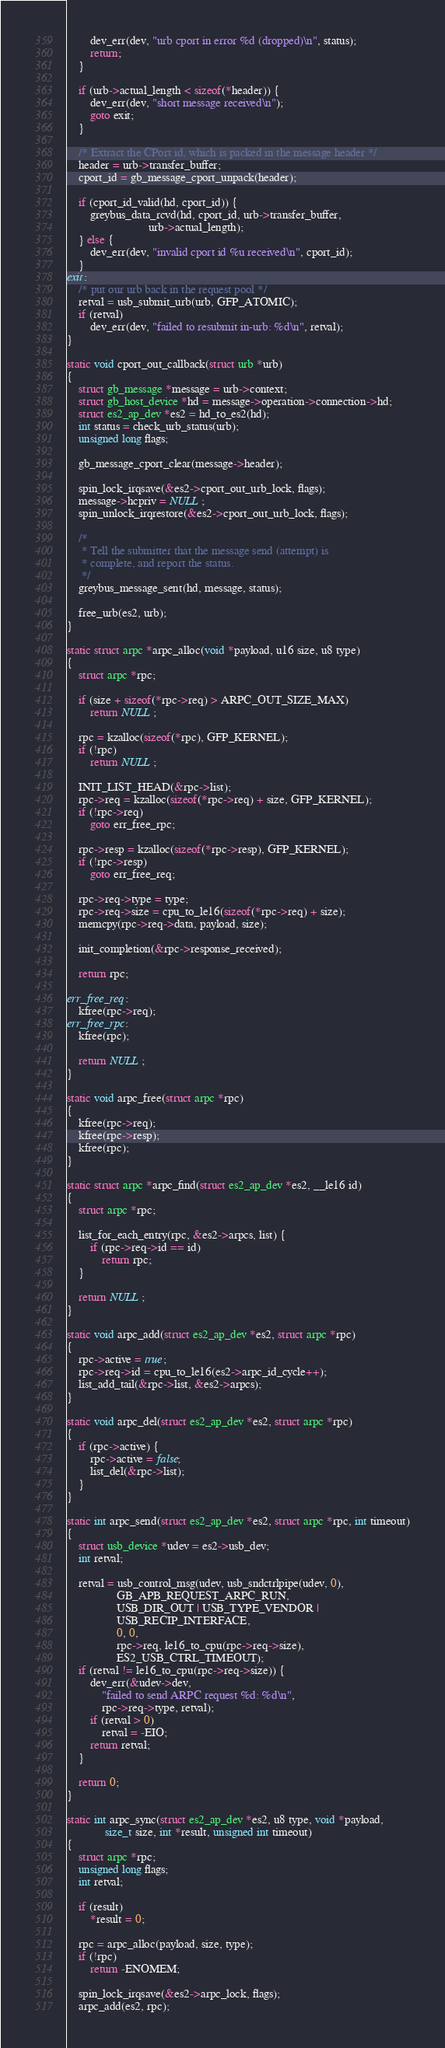Convert code to text. <code><loc_0><loc_0><loc_500><loc_500><_C_>
		dev_err(dev, "urb cport in error %d (dropped)\n", status);
		return;
	}

	if (urb->actual_length < sizeof(*header)) {
		dev_err(dev, "short message received\n");
		goto exit;
	}

	/* Extract the CPort id, which is packed in the message header */
	header = urb->transfer_buffer;
	cport_id = gb_message_cport_unpack(header);

	if (cport_id_valid(hd, cport_id)) {
		greybus_data_rcvd(hd, cport_id, urb->transfer_buffer,
							urb->actual_length);
	} else {
		dev_err(dev, "invalid cport id %u received\n", cport_id);
	}
exit:
	/* put our urb back in the request pool */
	retval = usb_submit_urb(urb, GFP_ATOMIC);
	if (retval)
		dev_err(dev, "failed to resubmit in-urb: %d\n", retval);
}

static void cport_out_callback(struct urb *urb)
{
	struct gb_message *message = urb->context;
	struct gb_host_device *hd = message->operation->connection->hd;
	struct es2_ap_dev *es2 = hd_to_es2(hd);
	int status = check_urb_status(urb);
	unsigned long flags;

	gb_message_cport_clear(message->header);

	spin_lock_irqsave(&es2->cport_out_urb_lock, flags);
	message->hcpriv = NULL;
	spin_unlock_irqrestore(&es2->cport_out_urb_lock, flags);

	/*
	 * Tell the submitter that the message send (attempt) is
	 * complete, and report the status.
	 */
	greybus_message_sent(hd, message, status);

	free_urb(es2, urb);
}

static struct arpc *arpc_alloc(void *payload, u16 size, u8 type)
{
	struct arpc *rpc;

	if (size + sizeof(*rpc->req) > ARPC_OUT_SIZE_MAX)
		return NULL;

	rpc = kzalloc(sizeof(*rpc), GFP_KERNEL);
	if (!rpc)
		return NULL;

	INIT_LIST_HEAD(&rpc->list);
	rpc->req = kzalloc(sizeof(*rpc->req) + size, GFP_KERNEL);
	if (!rpc->req)
		goto err_free_rpc;

	rpc->resp = kzalloc(sizeof(*rpc->resp), GFP_KERNEL);
	if (!rpc->resp)
		goto err_free_req;

	rpc->req->type = type;
	rpc->req->size = cpu_to_le16(sizeof(*rpc->req) + size);
	memcpy(rpc->req->data, payload, size);

	init_completion(&rpc->response_received);

	return rpc;

err_free_req:
	kfree(rpc->req);
err_free_rpc:
	kfree(rpc);

	return NULL;
}

static void arpc_free(struct arpc *rpc)
{
	kfree(rpc->req);
	kfree(rpc->resp);
	kfree(rpc);
}

static struct arpc *arpc_find(struct es2_ap_dev *es2, __le16 id)
{
	struct arpc *rpc;

	list_for_each_entry(rpc, &es2->arpcs, list) {
		if (rpc->req->id == id)
			return rpc;
	}

	return NULL;
}

static void arpc_add(struct es2_ap_dev *es2, struct arpc *rpc)
{
	rpc->active = true;
	rpc->req->id = cpu_to_le16(es2->arpc_id_cycle++);
	list_add_tail(&rpc->list, &es2->arpcs);
}

static void arpc_del(struct es2_ap_dev *es2, struct arpc *rpc)
{
	if (rpc->active) {
		rpc->active = false;
		list_del(&rpc->list);
	}
}

static int arpc_send(struct es2_ap_dev *es2, struct arpc *rpc, int timeout)
{
	struct usb_device *udev = es2->usb_dev;
	int retval;

	retval = usb_control_msg(udev, usb_sndctrlpipe(udev, 0),
				 GB_APB_REQUEST_ARPC_RUN,
				 USB_DIR_OUT | USB_TYPE_VENDOR |
				 USB_RECIP_INTERFACE,
				 0, 0,
				 rpc->req, le16_to_cpu(rpc->req->size),
				 ES2_USB_CTRL_TIMEOUT);
	if (retval != le16_to_cpu(rpc->req->size)) {
		dev_err(&udev->dev,
			"failed to send ARPC request %d: %d\n",
			rpc->req->type, retval);
		if (retval > 0)
			retval = -EIO;
		return retval;
	}

	return 0;
}

static int arpc_sync(struct es2_ap_dev *es2, u8 type, void *payload,
		     size_t size, int *result, unsigned int timeout)
{
	struct arpc *rpc;
	unsigned long flags;
	int retval;

	if (result)
		*result = 0;

	rpc = arpc_alloc(payload, size, type);
	if (!rpc)
		return -ENOMEM;

	spin_lock_irqsave(&es2->arpc_lock, flags);
	arpc_add(es2, rpc);</code> 